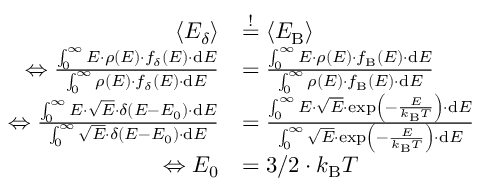Convert formula to latex. <formula><loc_0><loc_0><loc_500><loc_500>\begin{array} { r l } { \langle E _ { \delta } \rangle } & { \overset { ! } { = } \langle E _ { B } \rangle } \\ { \Leftrightarrow \frac { \int _ { 0 } ^ { \infty } E \cdot \rho ( E ) \cdot f _ { \delta } ( E ) \cdot d E } { \int _ { 0 } ^ { \infty } \rho ( E ) \cdot f _ { \delta } ( E ) \cdot d E } } & { = \frac { \int _ { 0 } ^ { \infty } E \cdot \rho ( E ) \cdot f _ { B } ( E ) \cdot d E } { \int _ { 0 } ^ { \infty } \rho ( E ) \cdot f _ { B } ( E ) \cdot d E } } \\ { \Leftrightarrow \frac { \int _ { 0 } ^ { \infty } E \cdot \sqrt { E } \cdot \delta ( E - E _ { 0 } ) \cdot d E } { \int _ { 0 } ^ { \infty } \sqrt { E } \cdot \delta ( E - E _ { 0 } ) \cdot d E } } & { = \frac { \int _ { 0 } ^ { \infty } E \cdot \sqrt { E } \cdot \exp \left ( - \frac { E } { k _ { B } T } \right ) \cdot d E } { \int _ { 0 } ^ { \infty } \sqrt { E } \cdot \exp \left ( - \frac { E } { k _ { B } T } \right ) \cdot d E } } \\ { \Leftrightarrow E _ { 0 } } & { = 3 / 2 \cdot k _ { B } T } \end{array}</formula> 